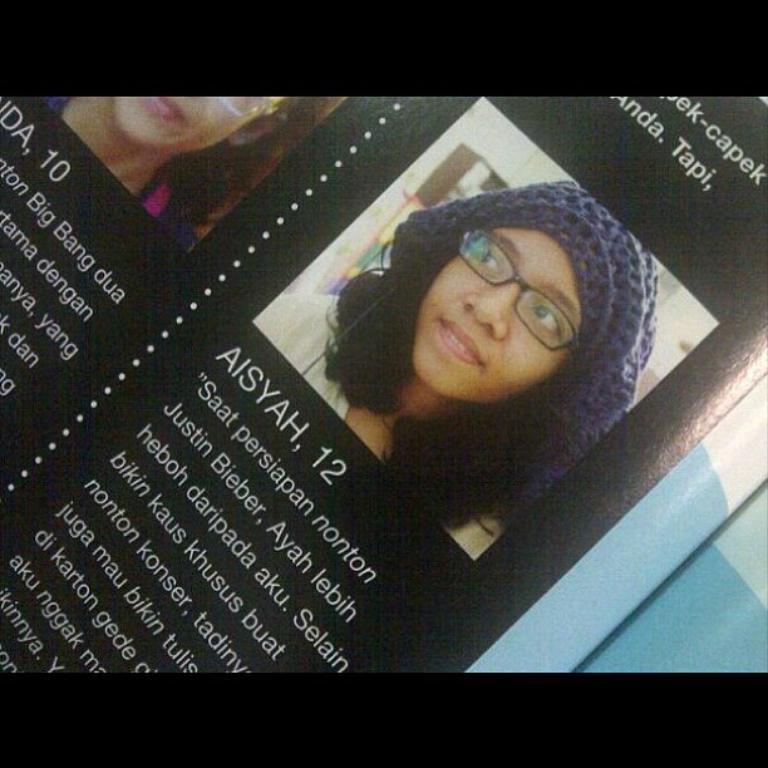What is the color of the paper in the image? The paper in the image is black. What is depicted on the paper? There are pictures of girls on the paper. What else can be found on the paper besides the images? There is text printed on the paper. How many times does the rhythm change in the image? There is no rhythm present in the image, as it is a static image of a black paper with pictures of girls and text. 